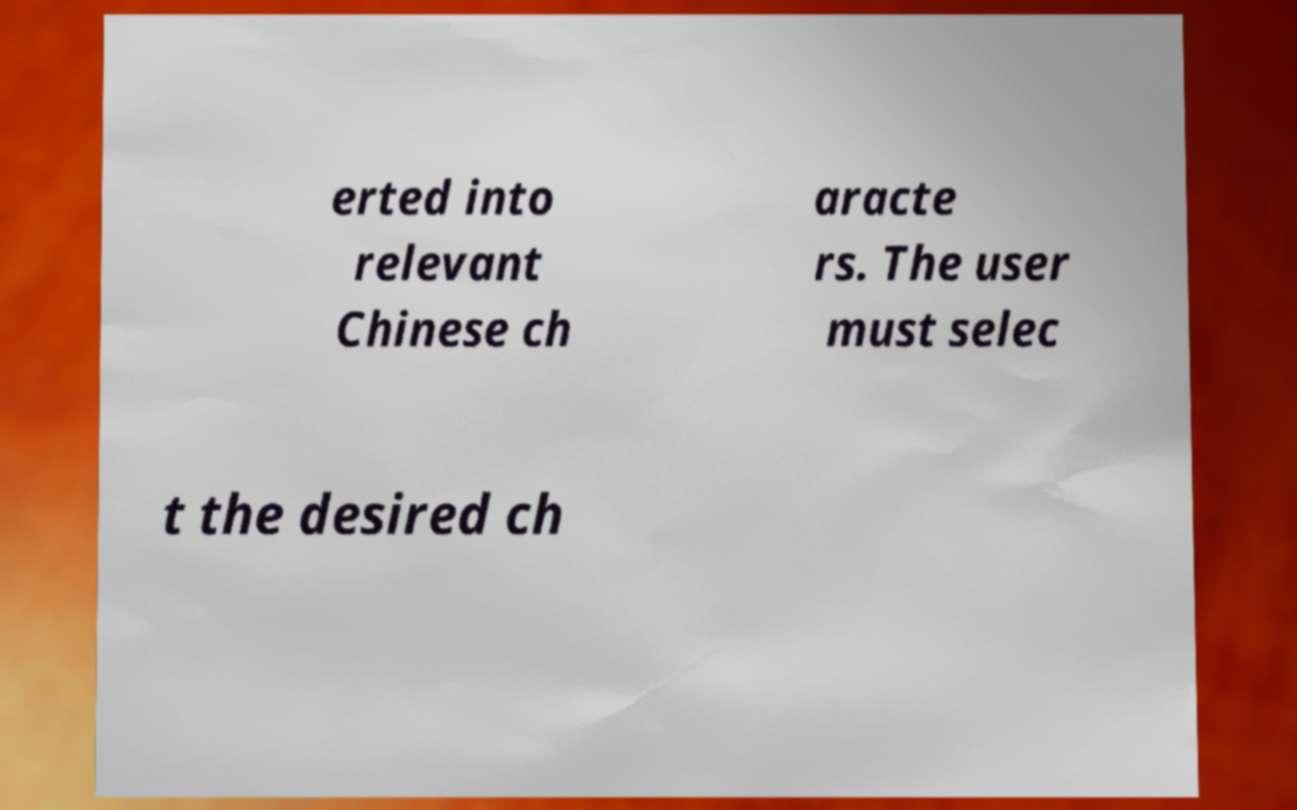What messages or text are displayed in this image? I need them in a readable, typed format. erted into relevant Chinese ch aracte rs. The user must selec t the desired ch 